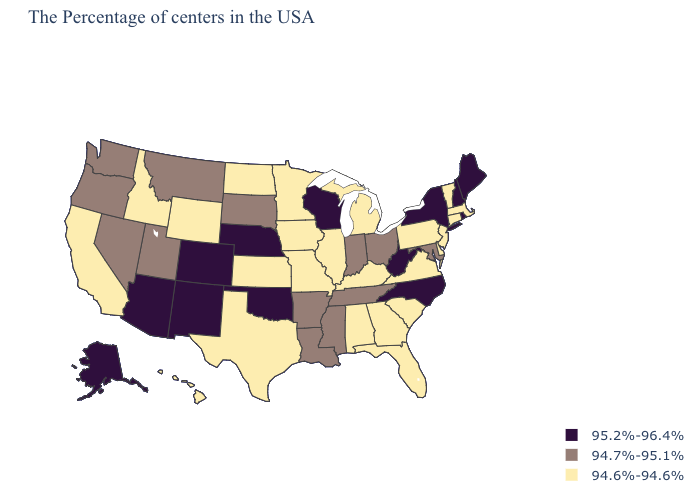Does Michigan have a higher value than Iowa?
Answer briefly. No. How many symbols are there in the legend?
Concise answer only. 3. What is the value of West Virginia?
Quick response, please. 95.2%-96.4%. What is the lowest value in states that border Michigan?
Short answer required. 94.7%-95.1%. What is the value of Florida?
Quick response, please. 94.6%-94.6%. Among the states that border Tennessee , does Virginia have the lowest value?
Write a very short answer. Yes. What is the lowest value in the MidWest?
Answer briefly. 94.6%-94.6%. Is the legend a continuous bar?
Be succinct. No. What is the lowest value in the West?
Be succinct. 94.6%-94.6%. What is the lowest value in the Northeast?
Keep it brief. 94.6%-94.6%. What is the lowest value in the USA?
Quick response, please. 94.6%-94.6%. What is the value of New Mexico?
Short answer required. 95.2%-96.4%. Name the states that have a value in the range 94.6%-94.6%?
Concise answer only. Massachusetts, Vermont, Connecticut, New Jersey, Delaware, Pennsylvania, Virginia, South Carolina, Florida, Georgia, Michigan, Kentucky, Alabama, Illinois, Missouri, Minnesota, Iowa, Kansas, Texas, North Dakota, Wyoming, Idaho, California, Hawaii. Does Maine have the same value as North Carolina?
Keep it brief. Yes. Does Mississippi have the lowest value in the South?
Answer briefly. No. 